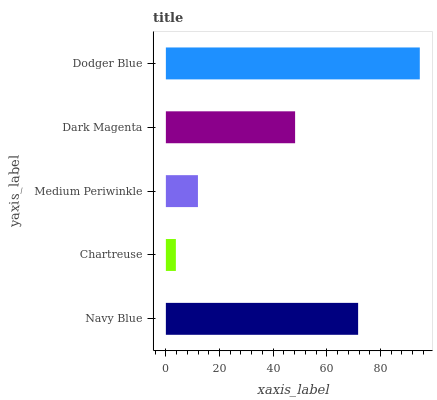Is Chartreuse the minimum?
Answer yes or no. Yes. Is Dodger Blue the maximum?
Answer yes or no. Yes. Is Medium Periwinkle the minimum?
Answer yes or no. No. Is Medium Periwinkle the maximum?
Answer yes or no. No. Is Medium Periwinkle greater than Chartreuse?
Answer yes or no. Yes. Is Chartreuse less than Medium Periwinkle?
Answer yes or no. Yes. Is Chartreuse greater than Medium Periwinkle?
Answer yes or no. No. Is Medium Periwinkle less than Chartreuse?
Answer yes or no. No. Is Dark Magenta the high median?
Answer yes or no. Yes. Is Dark Magenta the low median?
Answer yes or no. Yes. Is Dodger Blue the high median?
Answer yes or no. No. Is Medium Periwinkle the low median?
Answer yes or no. No. 